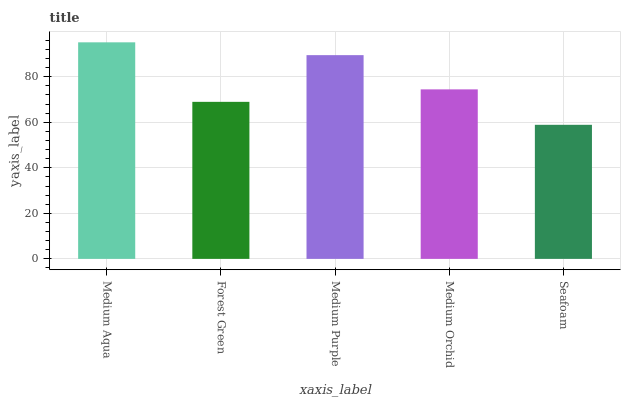Is Seafoam the minimum?
Answer yes or no. Yes. Is Medium Aqua the maximum?
Answer yes or no. Yes. Is Forest Green the minimum?
Answer yes or no. No. Is Forest Green the maximum?
Answer yes or no. No. Is Medium Aqua greater than Forest Green?
Answer yes or no. Yes. Is Forest Green less than Medium Aqua?
Answer yes or no. Yes. Is Forest Green greater than Medium Aqua?
Answer yes or no. No. Is Medium Aqua less than Forest Green?
Answer yes or no. No. Is Medium Orchid the high median?
Answer yes or no. Yes. Is Medium Orchid the low median?
Answer yes or no. Yes. Is Medium Aqua the high median?
Answer yes or no. No. Is Forest Green the low median?
Answer yes or no. No. 